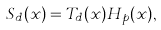Convert formula to latex. <formula><loc_0><loc_0><loc_500><loc_500>S _ { d } ( x ) = T _ { d } ( x ) H _ { p } ( x ) ,</formula> 